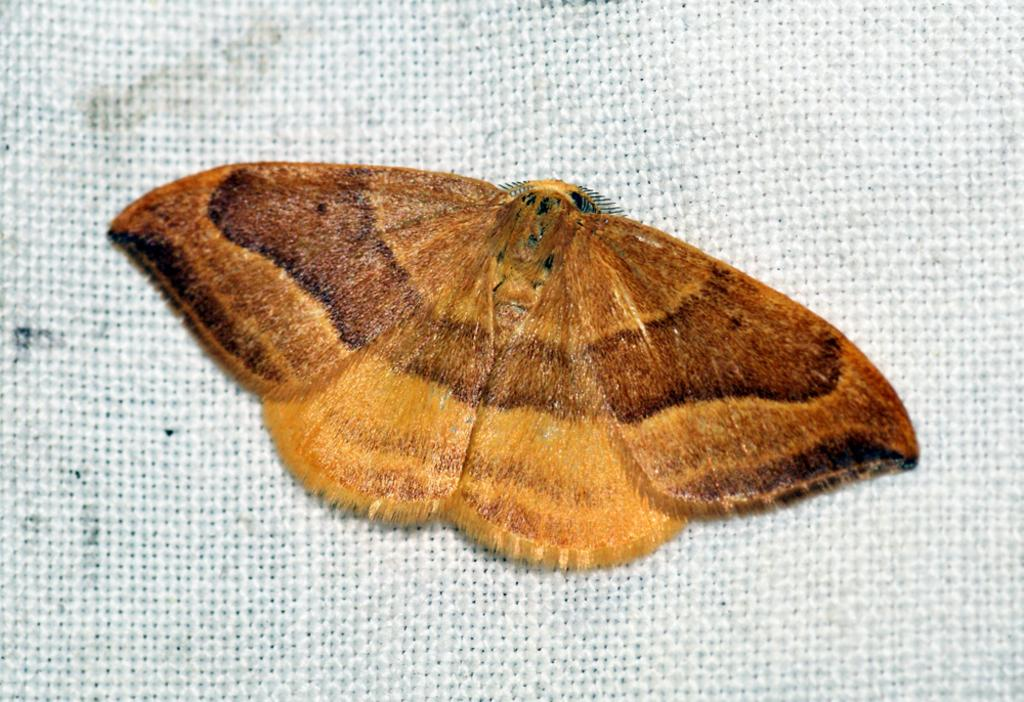What type of insect is in the picture? There is a brown color butterfly in the picture. What is the butterfly sitting on? The butterfly is sitting on a white color jute cloth. What type of machine is visible in the picture with the butterfly? There is no machine visible in the picture; it only features a brown color butterfly sitting on a white color jute cloth. 